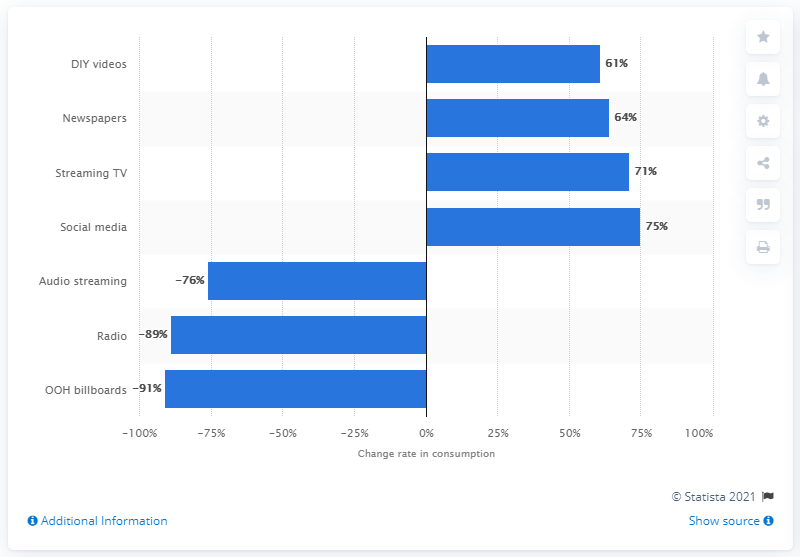Specify some key components in this picture. During a nation-wide lockdown due to COVID-19, a survey conducted in the first week revealed that the rate of social media consumption was 75%. 